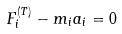<formula> <loc_0><loc_0><loc_500><loc_500>F _ { i } ^ { ( T ) } - m _ { i } a _ { i } = 0</formula> 